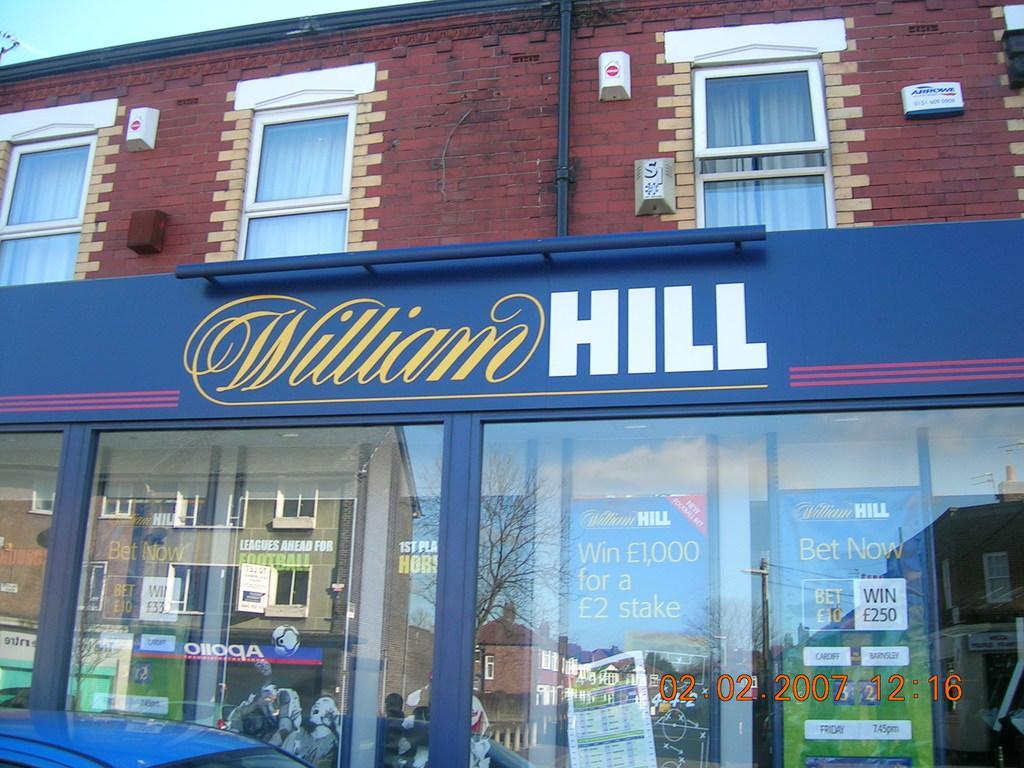In one or two sentences, can you explain what this image depicts? In this image we can see a building, sky, windows, pipelines, curtains, trees, information boards and a store. 